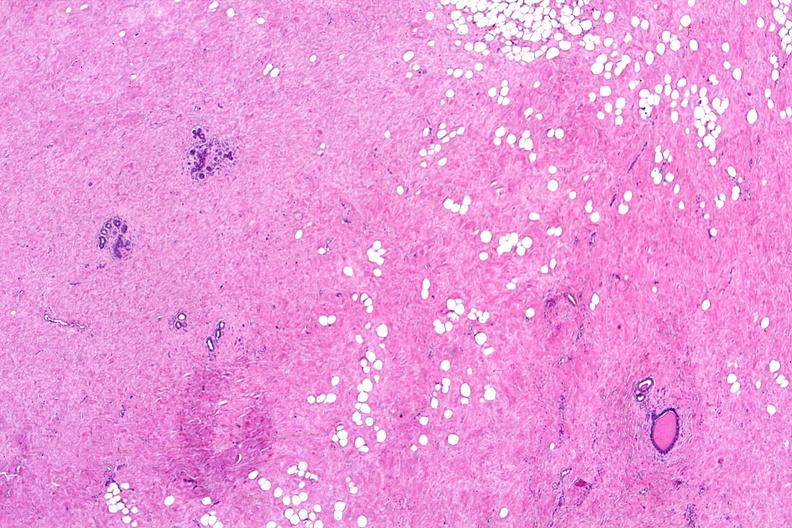s pituitectomy present?
Answer the question using a single word or phrase. No 